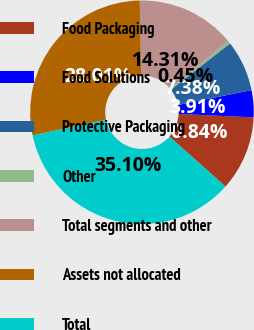Convert chart to OTSL. <chart><loc_0><loc_0><loc_500><loc_500><pie_chart><fcel>Food Packaging<fcel>Food Solutions<fcel>Protective Packaging<fcel>Other<fcel>Total segments and other<fcel>Assets not allocated<fcel>Total<nl><fcel>10.84%<fcel>3.91%<fcel>7.38%<fcel>0.45%<fcel>14.31%<fcel>28.01%<fcel>35.1%<nl></chart> 